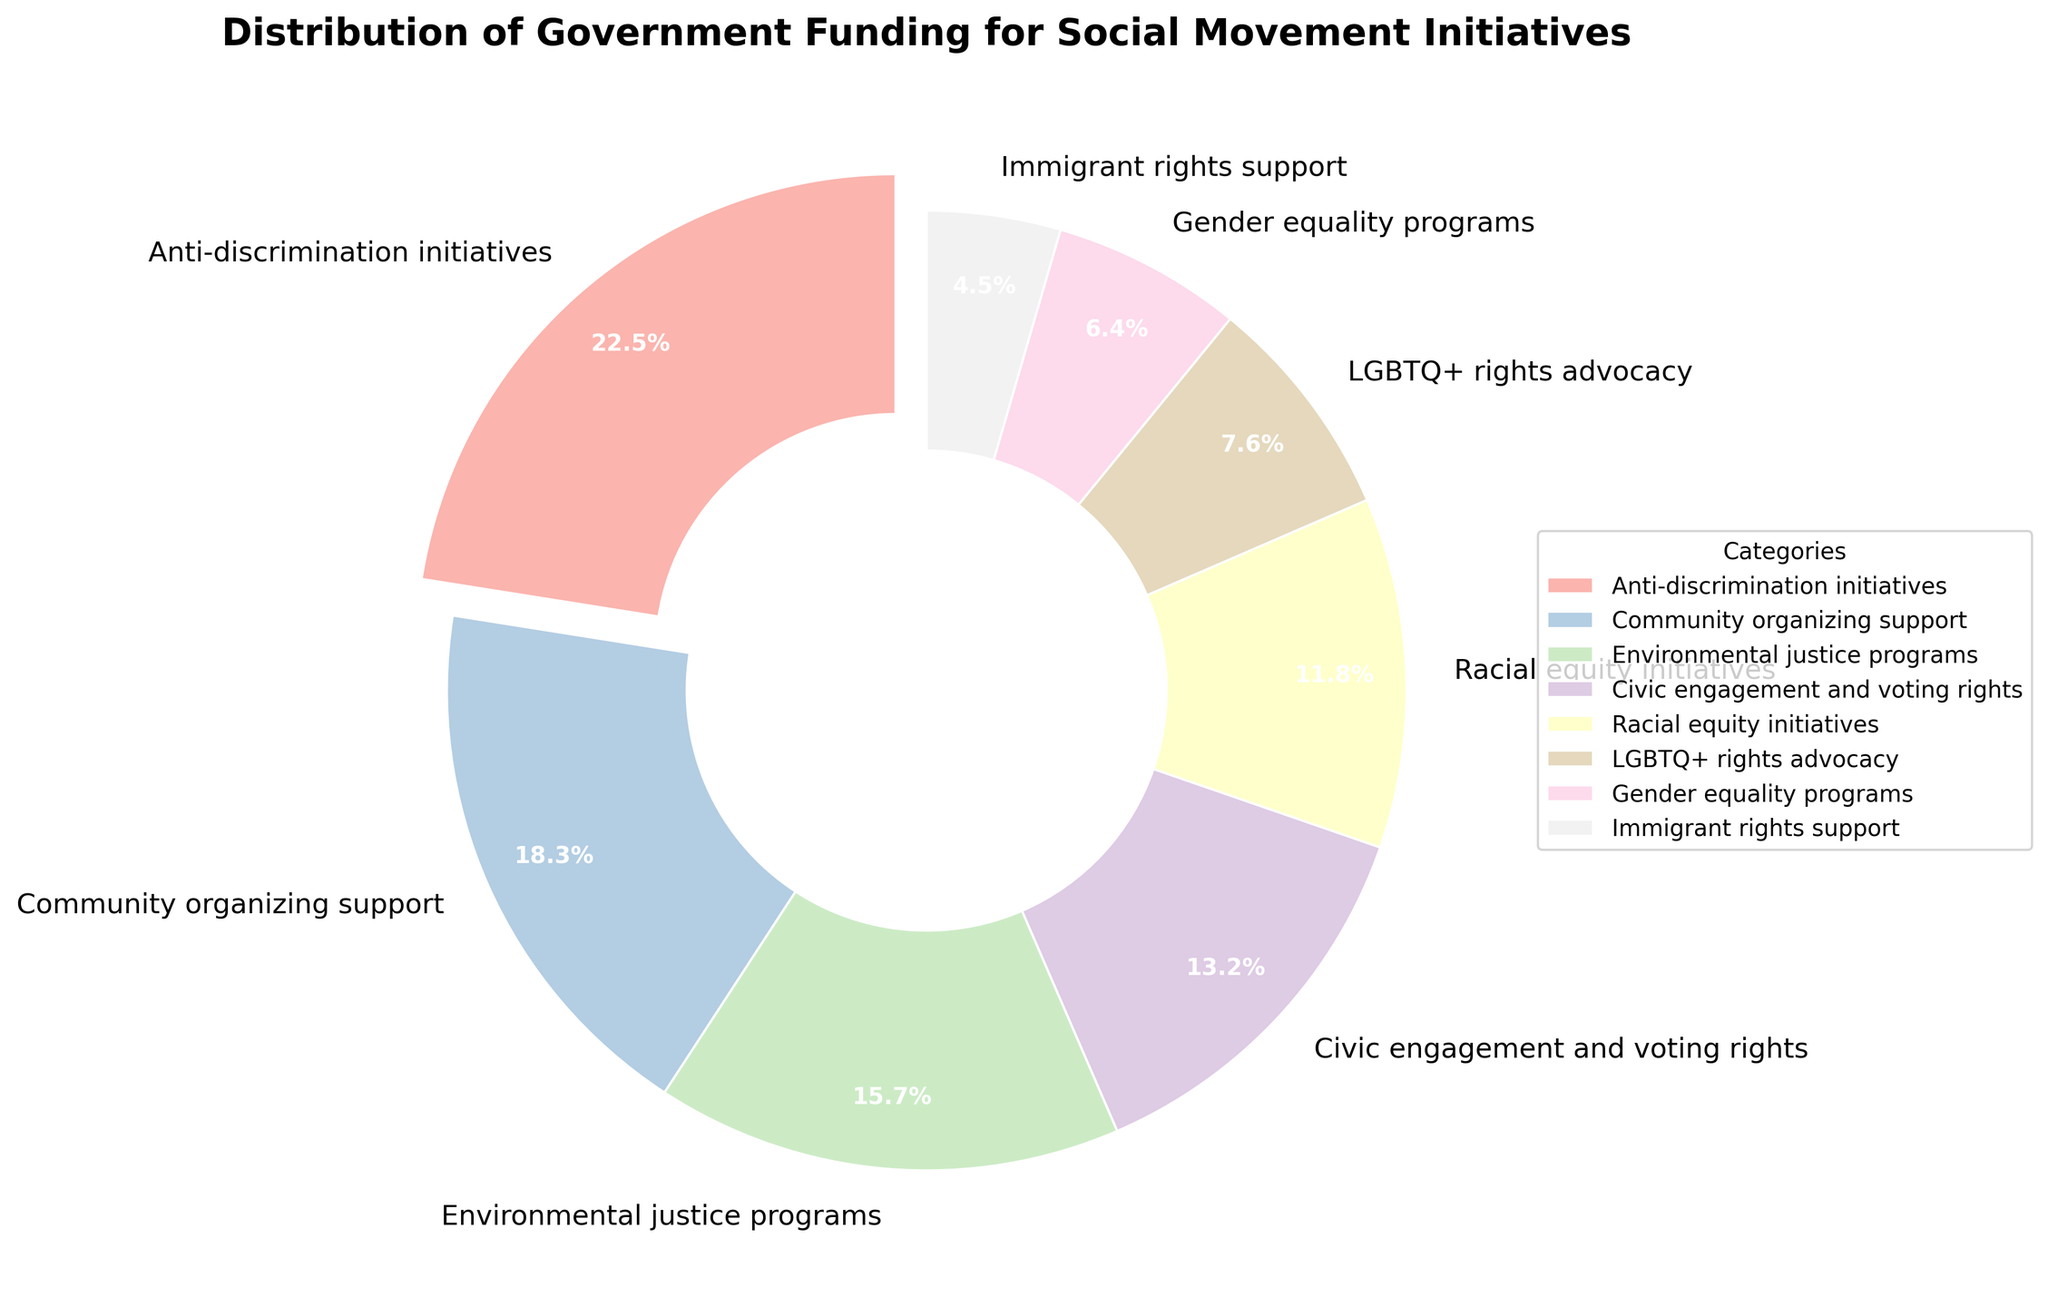Which category receives the largest allocation of government funding? The pie chart shows the percentage allocations for different categories. The largest segment, which also has an exploded slice, represents Anti-discrimination initiatives at 22.5%.
Answer: Anti-discrimination initiatives Which category receives the smallest allocation of government funding? The pie chart shows the percentage allocations for different categories. The smallest segment represents Immigrant rights support at 4.5%.
Answer: Immigrant rights support What's the combined percentage of government funding for both Community organizing support and Environmental justice programs? The pie chart shows 18.3% for Community organizing support and 15.7% for Environmental justice programs. Adding these percentages together gives 18.3 + 15.7 = 34%.
Answer: 34% How does the percentage of funding for Civic engagement and voting rights compare to Racial equity initiatives? The pie chart provides these percentages: Civic engagement and voting rights at 13.2% and Racial equity initiatives at 11.8%. Comparing the two values, Civic engagement and voting rights have a higher percentage.
Answer: Civic engagement and voting rights have a higher percentage What is the total percentage allocated to Anti-discrimination initiatives and LGBTQ+ rights advocacy? The pie chart shows the percentages: Anti-discrimination initiatives are 22.5% and LGBTQ+ rights advocacy is 7.6%. Adding these gives 22.5 + 7.6 = 30.1%.
Answer: 30.1% How much more percentage of funding does Anti-discrimination initiatives receive compared to Gender equality programs? The pie chart shows Anti-discrimination initiatives at 22.5% and Gender equality programs at 6.4%. Subtracting the two values, 22.5 - 6.4 = 16.1%.
Answer: 16.1% Which category is represented by the color that is typically associated with environmental themes? According to the pie chart colors, Environmental justice programs are usually associated with green shades. The slice for Environmental justice programs reflects this with a nature-associated color.
Answer: Environmental justice programs What percentage of the funding is allocated to initiatives targeting equality and rights (including Anti-discrimination initiatives, Racial equity initiatives, LGBTQ+ rights advocacy, and Gender equality programs)? The pie chart shows the percentages: Anti-discrimination initiatives are 22.5%, Racial equity initiatives are 11.8%, LGBTQ+ rights advocacy is 7.6%, and Gender equality programs are 6.4%. Adding these together gives 22.5 + 11.8 + 7.6 + 6.4 = 48.3%.
Answer: 48.3% Is the funding for Community organizing support greater or smaller than the combined funding for Gender equality programs and Immigrant rights support? The pie chart percentages show: Community organizing support is 18.3%, Gender equality programs are 6.4%, and Immigrant rights support is 4.5%. Adding the latter two gives 6.4 + 4.5 = 10.9%. Community organizing support (18.3%) is greater than the combined (10.9%).
Answer: Greater What is the difference in funding between Civic engagement and voting rights and Environmental justice programs? The pie chart shows Civic engagement and voting rights at 13.2% and Environmental justice programs at 15.7%. Subtracting the two values gives 15.7 - 13.2 = 2.5%.
Answer: 2.5% 